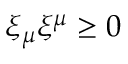Convert formula to latex. <formula><loc_0><loc_0><loc_500><loc_500>\xi _ { \mu } \xi ^ { \mu } \geq 0</formula> 